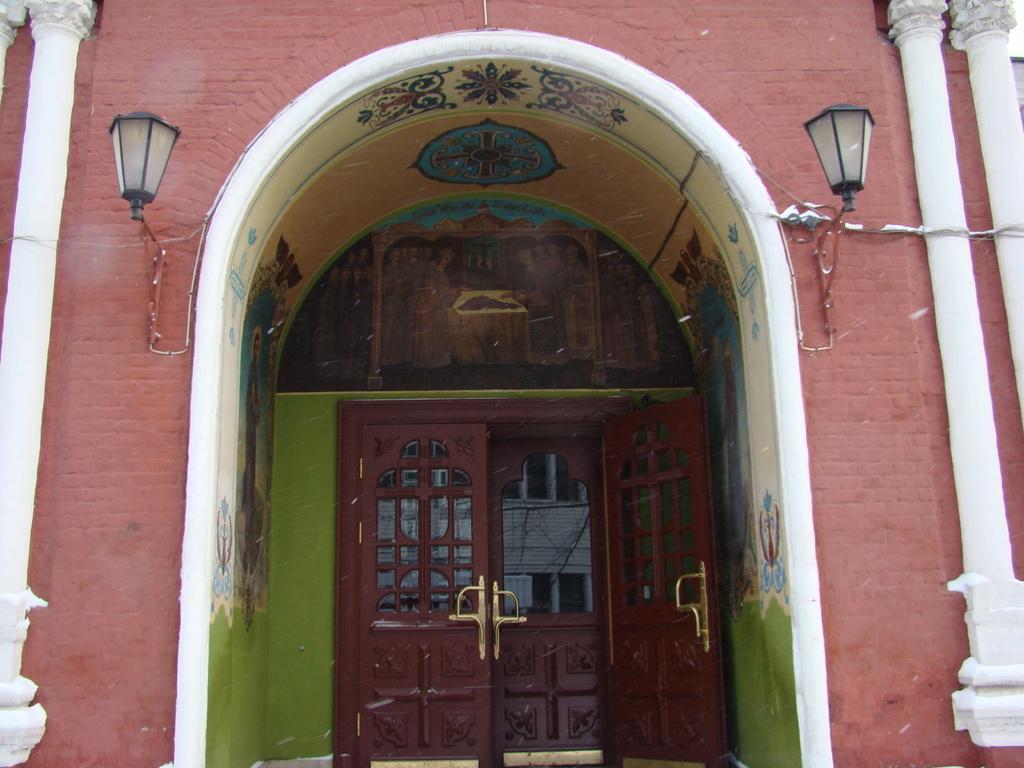Please provide a concise description of this image. This is the front view of a building, in this image there is a closed wooden door, beside the door there are lamps on the wall. 